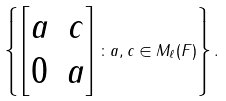<formula> <loc_0><loc_0><loc_500><loc_500>\left \{ \begin{bmatrix} a & c \\ 0 & a \end{bmatrix} \colon a , c \in M _ { \ell } ( F ) \right \} .</formula> 